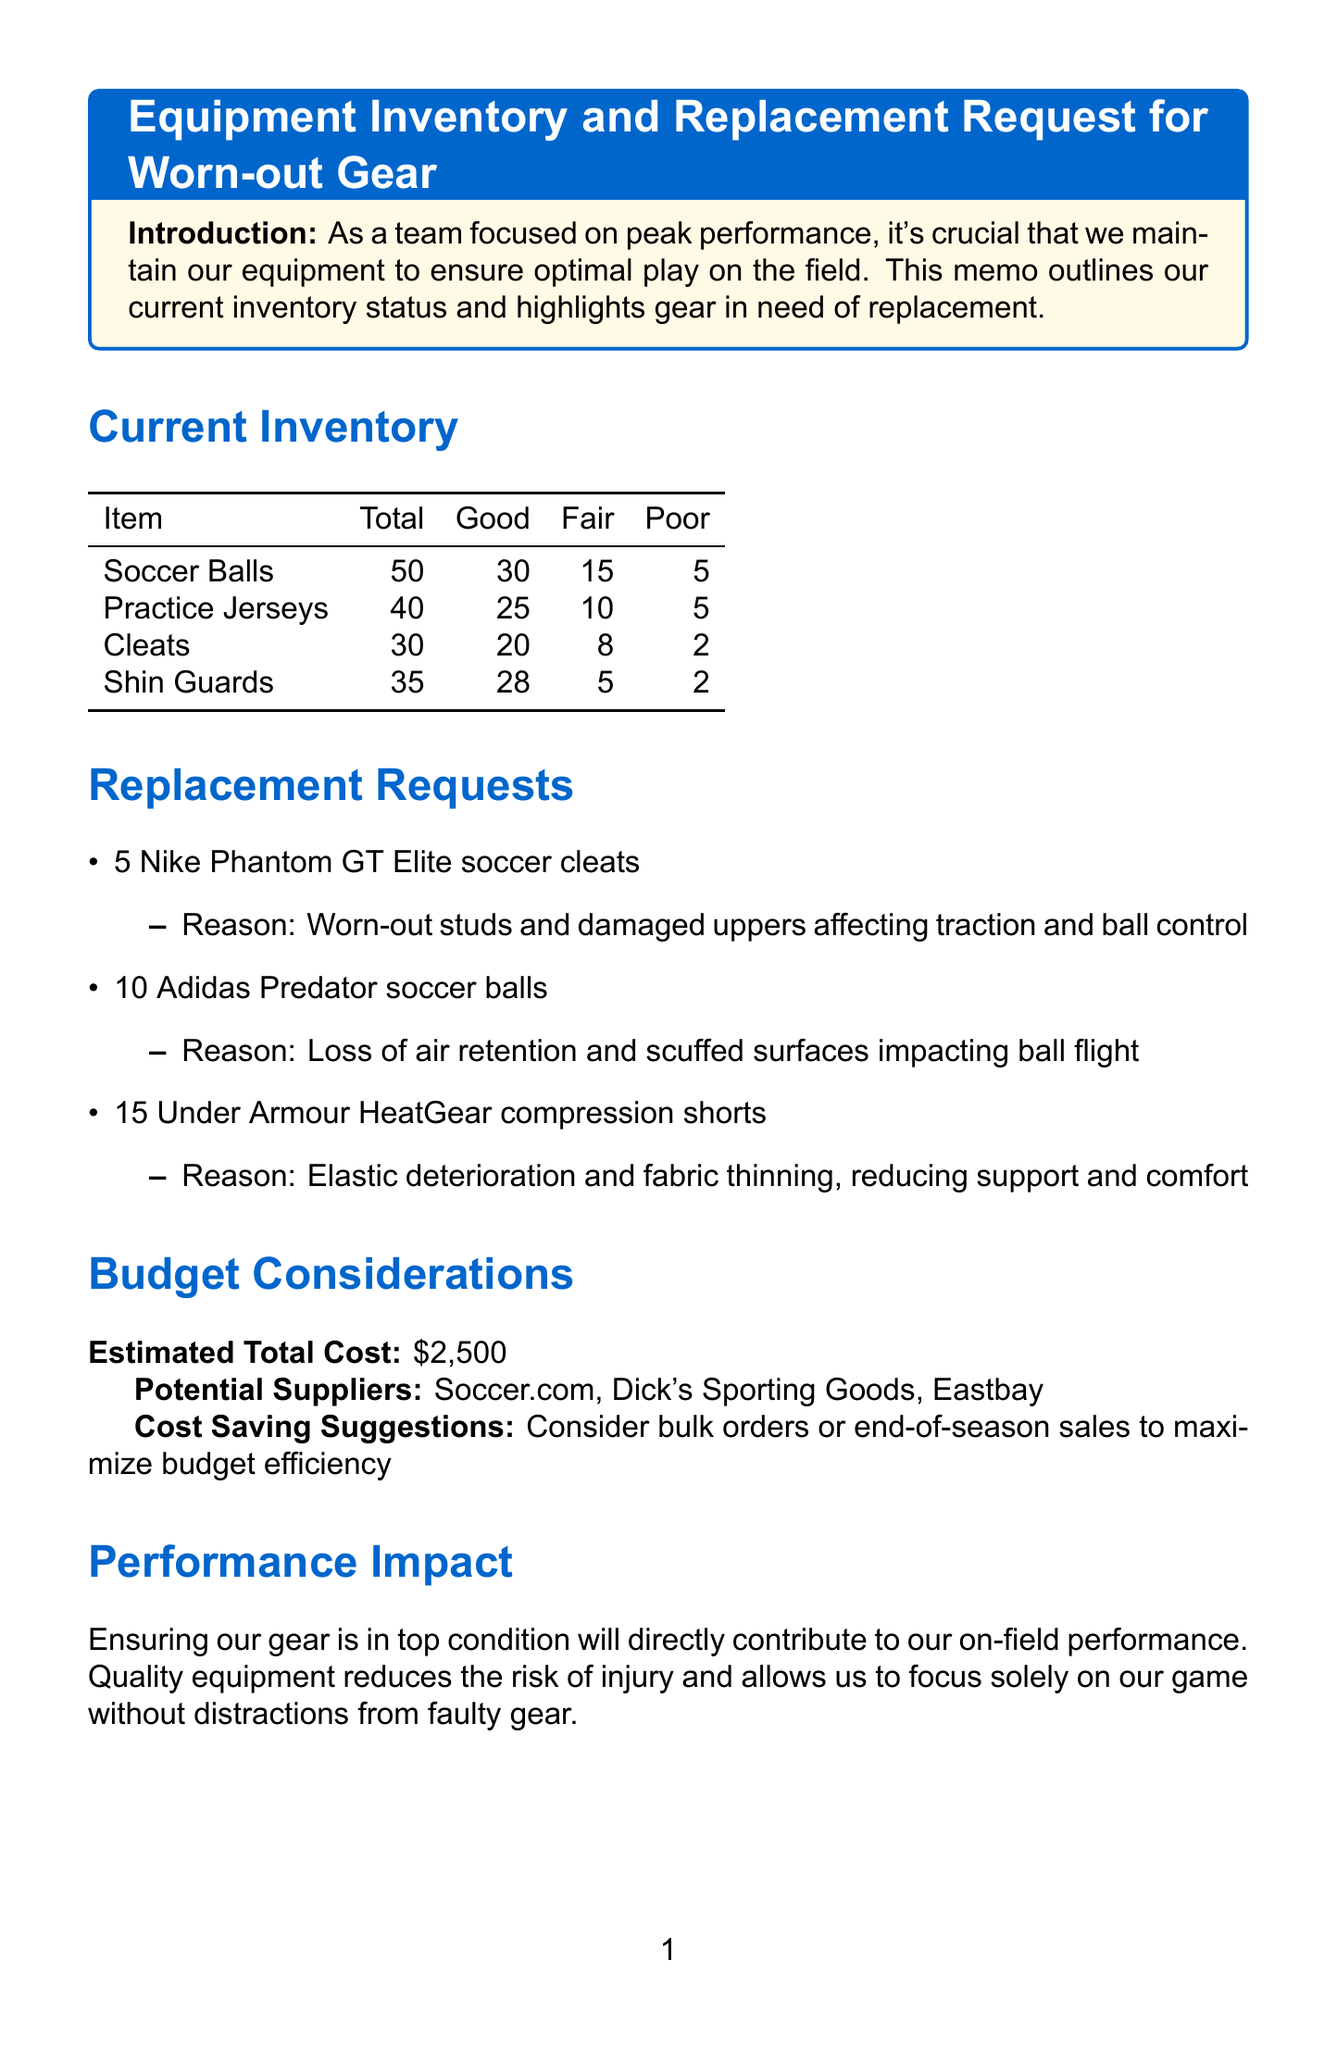What is the total number of soccer balls? The total number of soccer balls is provided in the current inventory section of the document.
Answer: 50 How many pairs of cleats are in poor condition? The number of cleats in poor condition can be found under the condition of cleats in the current inventory section.
Answer: 2 What is the estimated total cost for equipment replacement? The estimated total cost is mentioned explicitly in the budget considerations section of the memo.
Answer: $2,500 Which item has the most units in good condition? Analyzing the current inventory, the item with the most units in good condition can be determined by comparison.
Answer: Shin Guards What are the reasons for replacing the Adidas Predator soccer balls? The reasons for replacement is outlined alongside the item in the replacement requests section of the memo.
Answer: Loss of air retention and scuffed surfaces impacting ball flight How many practice jerseys are in fair condition? This number can be directly identified from the current inventory section regarding practice jerseys.
Answer: 10 Which supplier is listed as a potential source for new equipment? The potential suppliers are enumerated in the budget considerations section of the document.
Answer: Soccer.com How many Under Armour HeatGear compression shorts are requested for replacement? The quantity requested for replacement is clearly stated in the replacement requests section.
Answer: 15 What is the main focus of the team as mentioned in the introduction? The introduction outlines the team's focus, which is critical to understanding the overall memo purpose.
Answer: Peak performance 